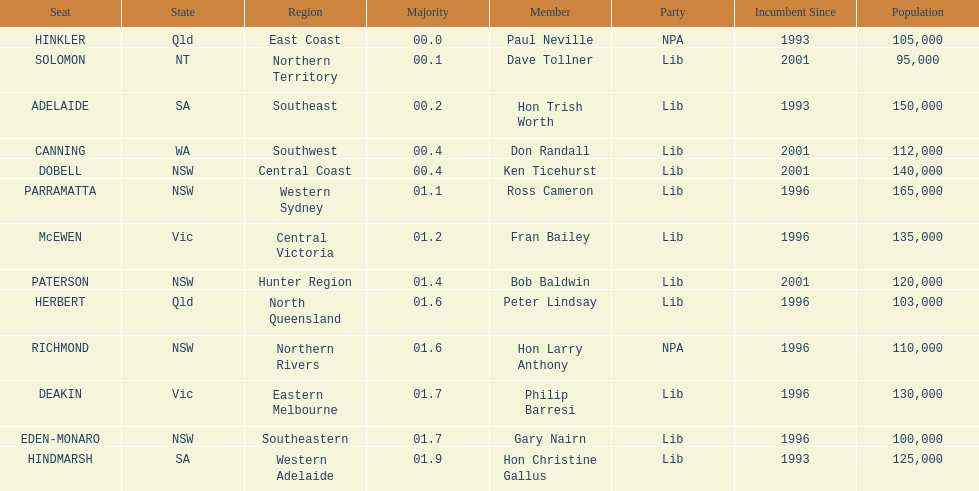What is the overall count of seats? 13. 